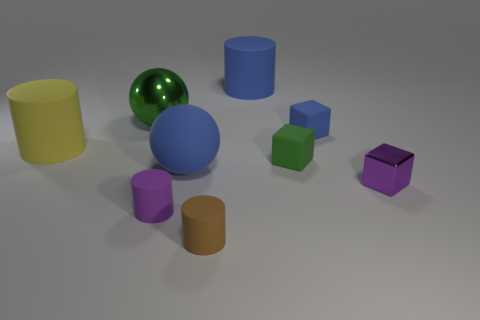How many yellow rubber cylinders are the same size as the blue block?
Your answer should be compact. 0. What is the color of the matte thing that is both on the left side of the small blue matte cube and behind the yellow cylinder?
Offer a very short reply. Blue. Is the number of big green metallic objects less than the number of big blue rubber things?
Provide a succinct answer. Yes. There is a shiny sphere; does it have the same color as the big rubber cylinder that is on the left side of the matte sphere?
Provide a succinct answer. No. Are there an equal number of blue rubber balls on the right side of the large green object and purple cylinders that are to the right of the tiny brown cylinder?
Provide a short and direct response. No. How many yellow matte things are the same shape as the big shiny thing?
Give a very brief answer. 0. Are any small brown things visible?
Provide a succinct answer. Yes. Do the big green thing and the purple thing that is in front of the purple metallic cube have the same material?
Your answer should be compact. No. What is the material of the green thing that is the same size as the yellow rubber cylinder?
Ensure brevity in your answer.  Metal. Is there a tiny yellow ball made of the same material as the big yellow cylinder?
Your answer should be very brief. No. 